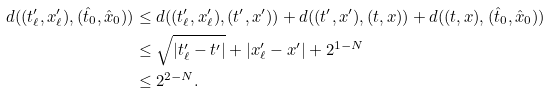<formula> <loc_0><loc_0><loc_500><loc_500>d ( ( t ^ { \prime } _ { \ell } , x ^ { \prime } _ { \ell } ) , ( \hat { t } _ { 0 } , \hat { x } _ { 0 } ) ) & \leq d ( ( t ^ { \prime } _ { \ell } , x ^ { \prime } _ { \ell } ) , ( t ^ { \prime } , x ^ { \prime } ) ) + d ( ( t ^ { \prime } , x ^ { \prime } ) , ( t , x ) ) + d ( ( t , x ) , ( \hat { t } _ { 0 } , \hat { x } _ { 0 } ) ) \\ & \leq \sqrt { | t ^ { \prime } _ { \ell } - t ^ { \prime } | } + | x ^ { \prime } _ { \ell } - x ^ { \prime } | + 2 ^ { 1 - N } \\ & \leq 2 ^ { 2 - N } .</formula> 